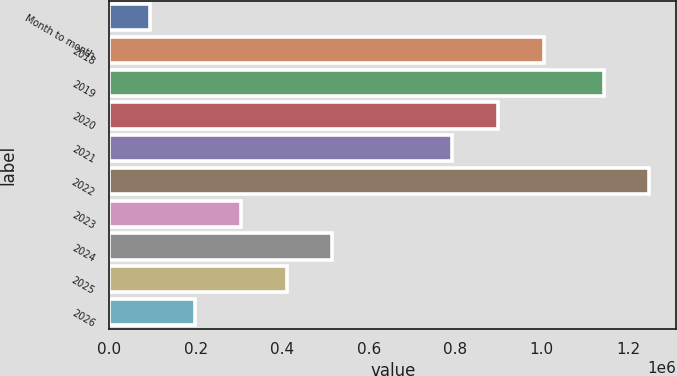<chart> <loc_0><loc_0><loc_500><loc_500><bar_chart><fcel>Month to month<fcel>2018<fcel>2019<fcel>2020<fcel>2021<fcel>2022<fcel>2023<fcel>2024<fcel>2025<fcel>2026<nl><fcel>93000<fcel>1.0042e+06<fcel>1.143e+06<fcel>898600<fcel>793000<fcel>1.2486e+06<fcel>304200<fcel>515400<fcel>409800<fcel>198600<nl></chart> 